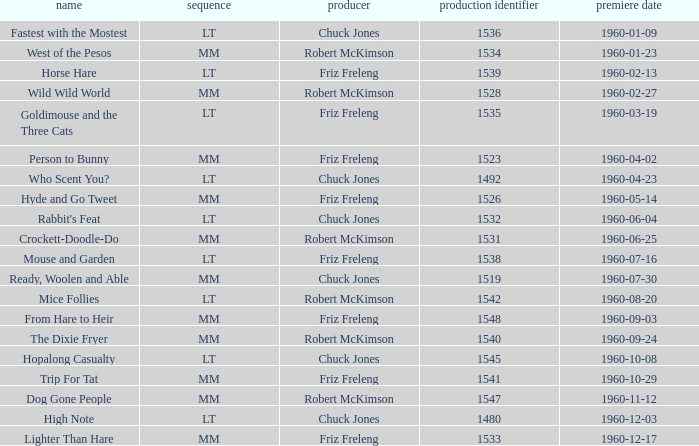What is the production number of From Hare to Heir? 1548.0. 